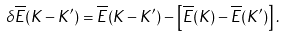Convert formula to latex. <formula><loc_0><loc_0><loc_500><loc_500>\delta \overline { E } ( K - K ^ { \prime } ) = \overline { E } ( K - K ^ { \prime } ) - \left [ \overline { E } ( K ) - \overline { E } ( K ^ { \prime } ) \right ] .</formula> 